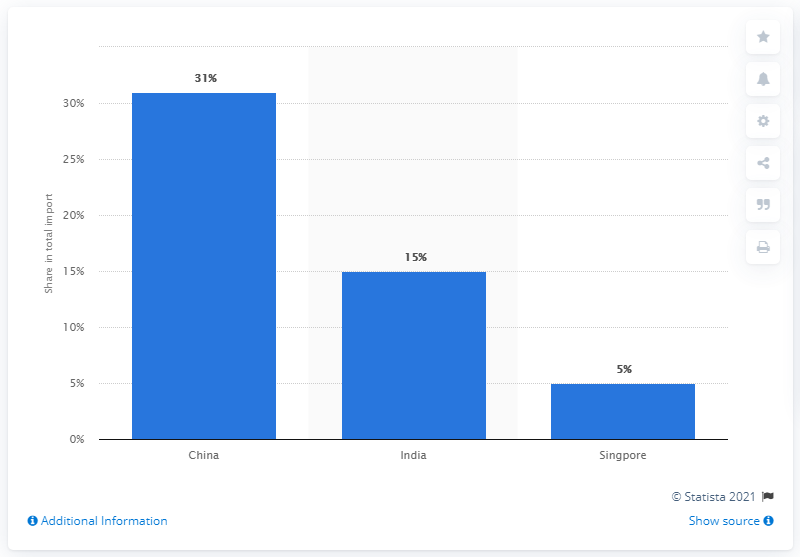Point out several critical features in this image. According to data from 2019, China was the most significant import partner for Bangladesh. 